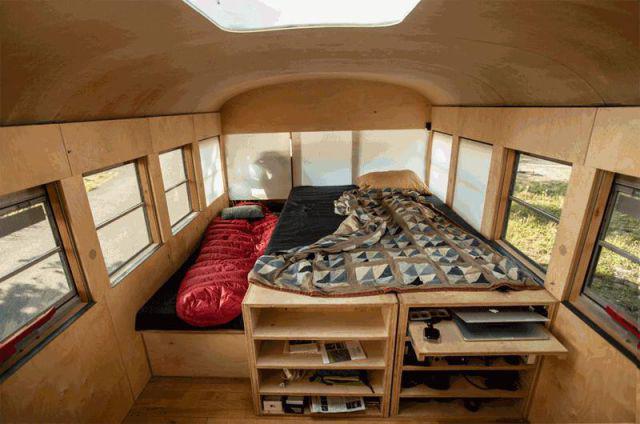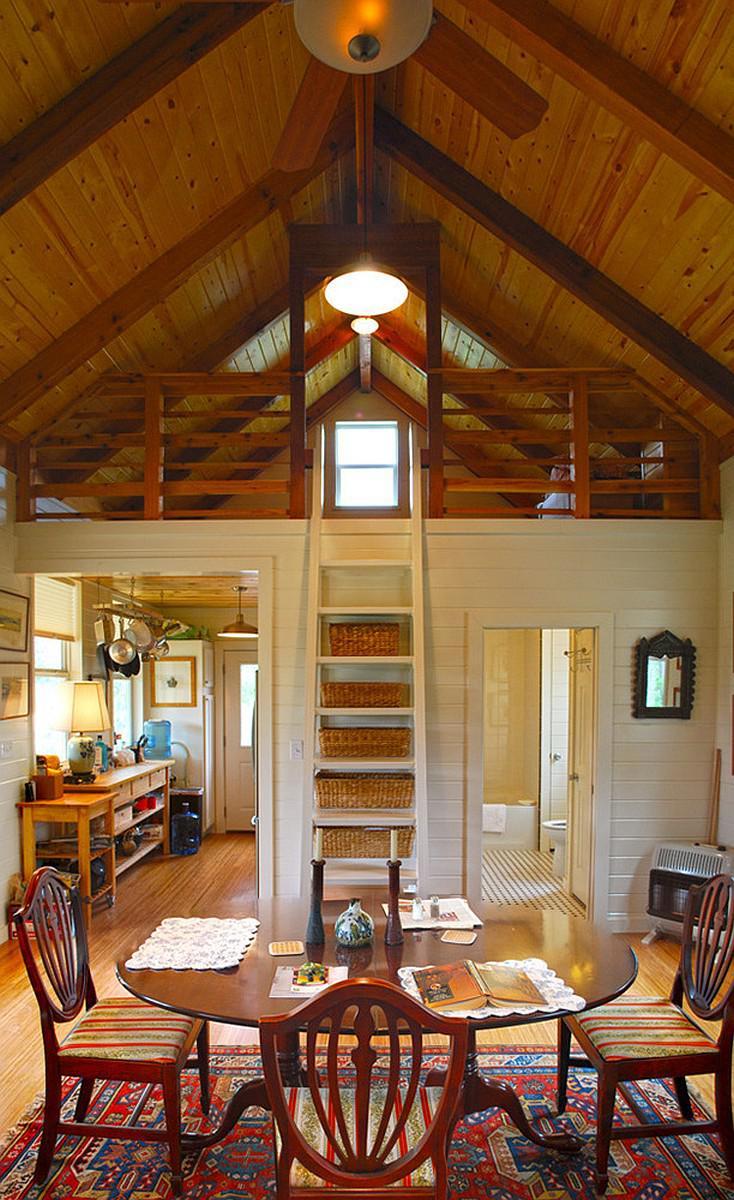The first image is the image on the left, the second image is the image on the right. Examine the images to the left and right. Is the description "The left image shows an interior with a convex curved ceiling that has a squarish skylight in it, and square windows running its length on both sides." accurate? Answer yes or no. Yes. 